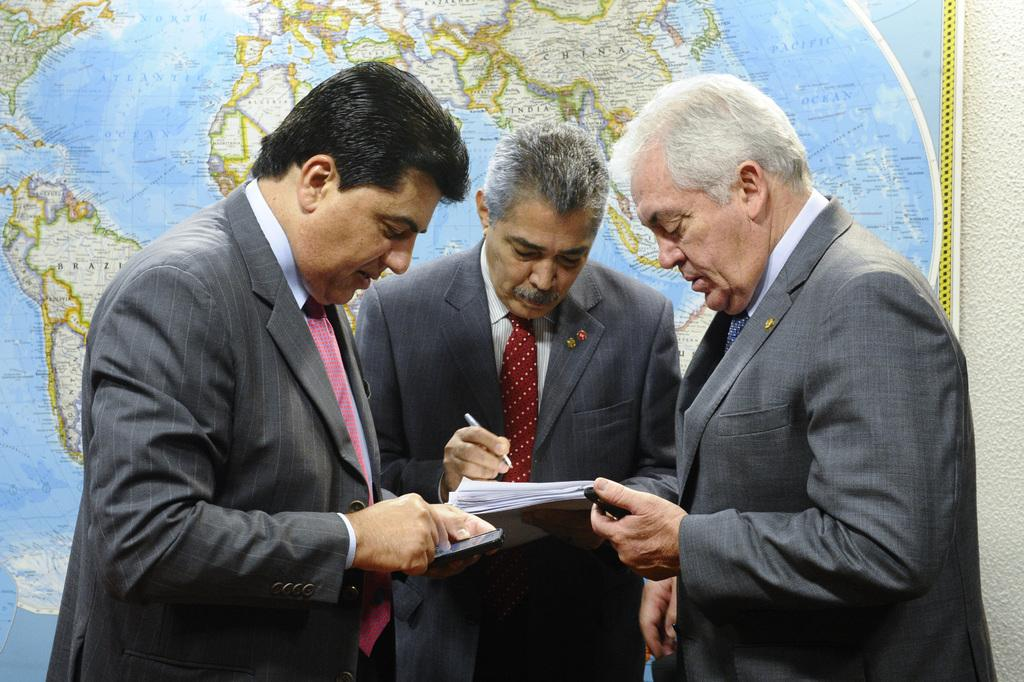What is happening in the center of the image? There are persons standing in the center of the image. What surface are the persons standing on? The persons are standing on the floor. What can be seen in the background of the image? There is a map in the background of the image. What color is the scarf worn by the person in the image? There is no scarf visible in the image. How many eyes does the lake have in the image? There is no lake present in the image. 